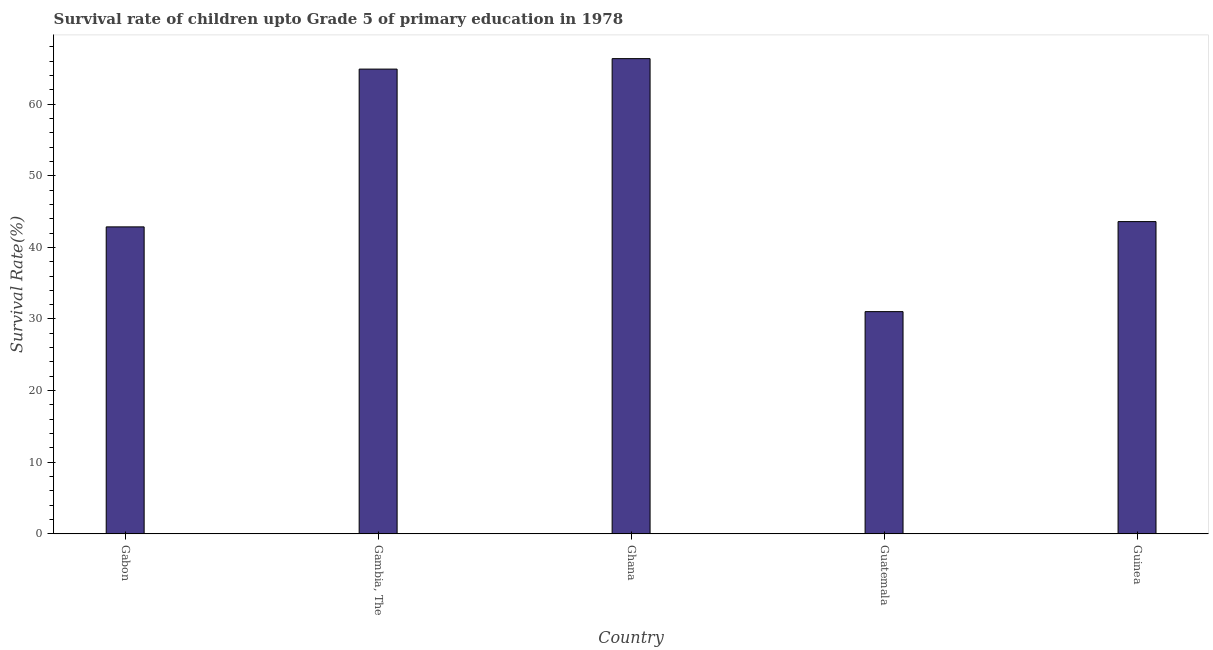Does the graph contain any zero values?
Ensure brevity in your answer.  No. What is the title of the graph?
Provide a short and direct response. Survival rate of children upto Grade 5 of primary education in 1978 . What is the label or title of the Y-axis?
Make the answer very short. Survival Rate(%). What is the survival rate in Guinea?
Make the answer very short. 43.6. Across all countries, what is the maximum survival rate?
Give a very brief answer. 66.35. Across all countries, what is the minimum survival rate?
Your response must be concise. 31.03. In which country was the survival rate maximum?
Make the answer very short. Ghana. In which country was the survival rate minimum?
Your answer should be very brief. Guatemala. What is the sum of the survival rate?
Ensure brevity in your answer.  248.73. What is the difference between the survival rate in Guatemala and Guinea?
Make the answer very short. -12.57. What is the average survival rate per country?
Ensure brevity in your answer.  49.74. What is the median survival rate?
Offer a very short reply. 43.6. What is the ratio of the survival rate in Ghana to that in Guinea?
Your response must be concise. 1.52. What is the difference between the highest and the second highest survival rate?
Offer a terse response. 1.46. Is the sum of the survival rate in Ghana and Guinea greater than the maximum survival rate across all countries?
Offer a very short reply. Yes. What is the difference between the highest and the lowest survival rate?
Offer a terse response. 35.32. How many bars are there?
Keep it short and to the point. 5. How many countries are there in the graph?
Your answer should be very brief. 5. What is the difference between two consecutive major ticks on the Y-axis?
Make the answer very short. 10. What is the Survival Rate(%) of Gabon?
Your response must be concise. 42.86. What is the Survival Rate(%) in Gambia, The?
Your response must be concise. 64.89. What is the Survival Rate(%) in Ghana?
Provide a short and direct response. 66.35. What is the Survival Rate(%) in Guatemala?
Your response must be concise. 31.03. What is the Survival Rate(%) of Guinea?
Ensure brevity in your answer.  43.6. What is the difference between the Survival Rate(%) in Gabon and Gambia, The?
Offer a very short reply. -22.03. What is the difference between the Survival Rate(%) in Gabon and Ghana?
Keep it short and to the point. -23.49. What is the difference between the Survival Rate(%) in Gabon and Guatemala?
Give a very brief answer. 11.83. What is the difference between the Survival Rate(%) in Gabon and Guinea?
Offer a terse response. -0.74. What is the difference between the Survival Rate(%) in Gambia, The and Ghana?
Provide a short and direct response. -1.46. What is the difference between the Survival Rate(%) in Gambia, The and Guatemala?
Make the answer very short. 33.86. What is the difference between the Survival Rate(%) in Gambia, The and Guinea?
Offer a very short reply. 21.29. What is the difference between the Survival Rate(%) in Ghana and Guatemala?
Your answer should be very brief. 35.32. What is the difference between the Survival Rate(%) in Ghana and Guinea?
Make the answer very short. 22.75. What is the difference between the Survival Rate(%) in Guatemala and Guinea?
Ensure brevity in your answer.  -12.57. What is the ratio of the Survival Rate(%) in Gabon to that in Gambia, The?
Offer a terse response. 0.66. What is the ratio of the Survival Rate(%) in Gabon to that in Ghana?
Make the answer very short. 0.65. What is the ratio of the Survival Rate(%) in Gabon to that in Guatemala?
Provide a succinct answer. 1.38. What is the ratio of the Survival Rate(%) in Gabon to that in Guinea?
Keep it short and to the point. 0.98. What is the ratio of the Survival Rate(%) in Gambia, The to that in Ghana?
Your response must be concise. 0.98. What is the ratio of the Survival Rate(%) in Gambia, The to that in Guatemala?
Ensure brevity in your answer.  2.09. What is the ratio of the Survival Rate(%) in Gambia, The to that in Guinea?
Offer a very short reply. 1.49. What is the ratio of the Survival Rate(%) in Ghana to that in Guatemala?
Make the answer very short. 2.14. What is the ratio of the Survival Rate(%) in Ghana to that in Guinea?
Your answer should be compact. 1.52. What is the ratio of the Survival Rate(%) in Guatemala to that in Guinea?
Your response must be concise. 0.71. 